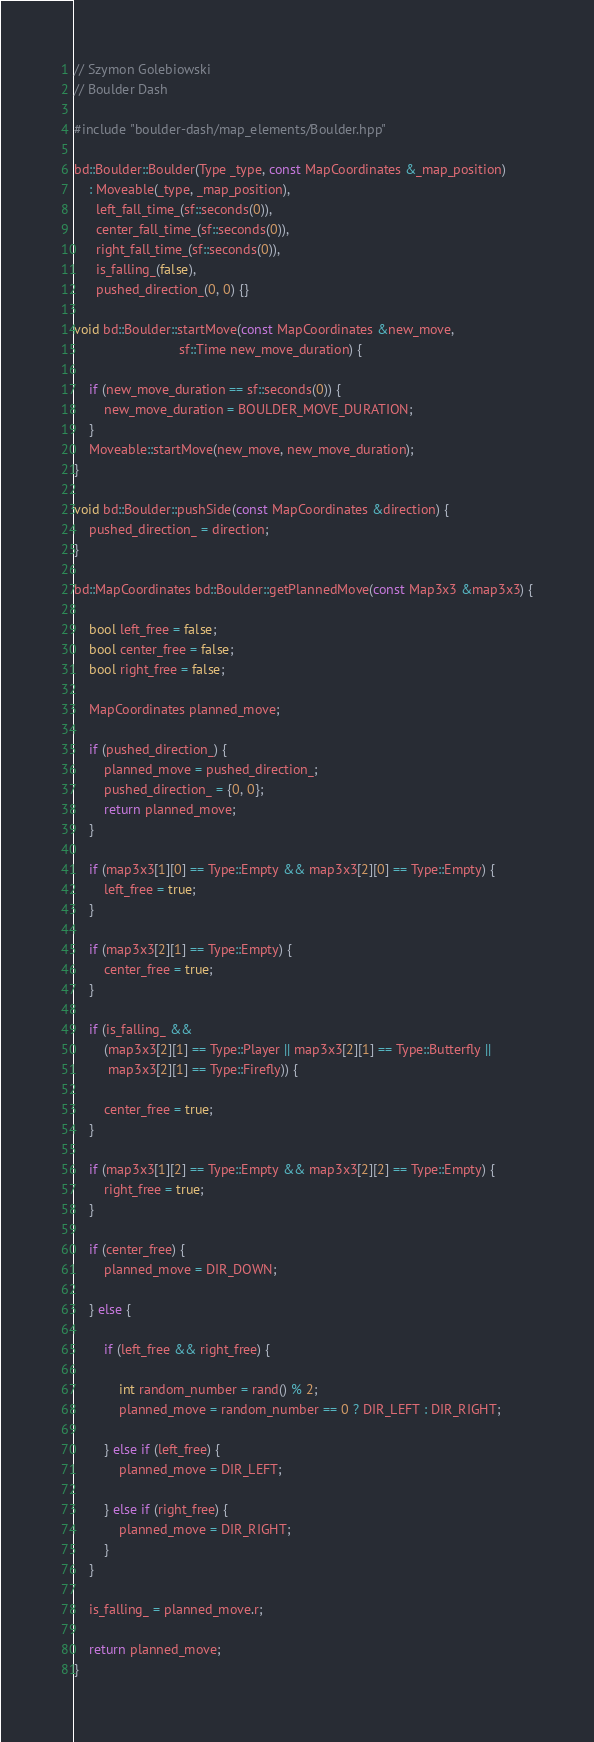<code> <loc_0><loc_0><loc_500><loc_500><_C++_>// Szymon Golebiowski
// Boulder Dash

#include "boulder-dash/map_elements/Boulder.hpp"

bd::Boulder::Boulder(Type _type, const MapCoordinates &_map_position)
    : Moveable(_type, _map_position),
      left_fall_time_(sf::seconds(0)),
      center_fall_time_(sf::seconds(0)),
      right_fall_time_(sf::seconds(0)),
      is_falling_(false),
      pushed_direction_(0, 0) {}

void bd::Boulder::startMove(const MapCoordinates &new_move,
                            sf::Time new_move_duration) {

    if (new_move_duration == sf::seconds(0)) {
        new_move_duration = BOULDER_MOVE_DURATION;
    }
    Moveable::startMove(new_move, new_move_duration);
}

void bd::Boulder::pushSide(const MapCoordinates &direction) {
    pushed_direction_ = direction;
}

bd::MapCoordinates bd::Boulder::getPlannedMove(const Map3x3 &map3x3) {

    bool left_free = false;
    bool center_free = false;
    bool right_free = false;

    MapCoordinates planned_move;

    if (pushed_direction_) {
        planned_move = pushed_direction_;
        pushed_direction_ = {0, 0};
        return planned_move;
    }

    if (map3x3[1][0] == Type::Empty && map3x3[2][0] == Type::Empty) {
        left_free = true;
    }

    if (map3x3[2][1] == Type::Empty) {
        center_free = true;
    }

    if (is_falling_ &&
        (map3x3[2][1] == Type::Player || map3x3[2][1] == Type::Butterfly ||
         map3x3[2][1] == Type::Firefly)) {

        center_free = true;
    }

    if (map3x3[1][2] == Type::Empty && map3x3[2][2] == Type::Empty) {
        right_free = true;
    }

    if (center_free) {
        planned_move = DIR_DOWN;

    } else {

        if (left_free && right_free) {

            int random_number = rand() % 2;
            planned_move = random_number == 0 ? DIR_LEFT : DIR_RIGHT;

        } else if (left_free) {
            planned_move = DIR_LEFT;

        } else if (right_free) {
            planned_move = DIR_RIGHT;
        }
    }

    is_falling_ = planned_move.r;

    return planned_move;
}</code> 